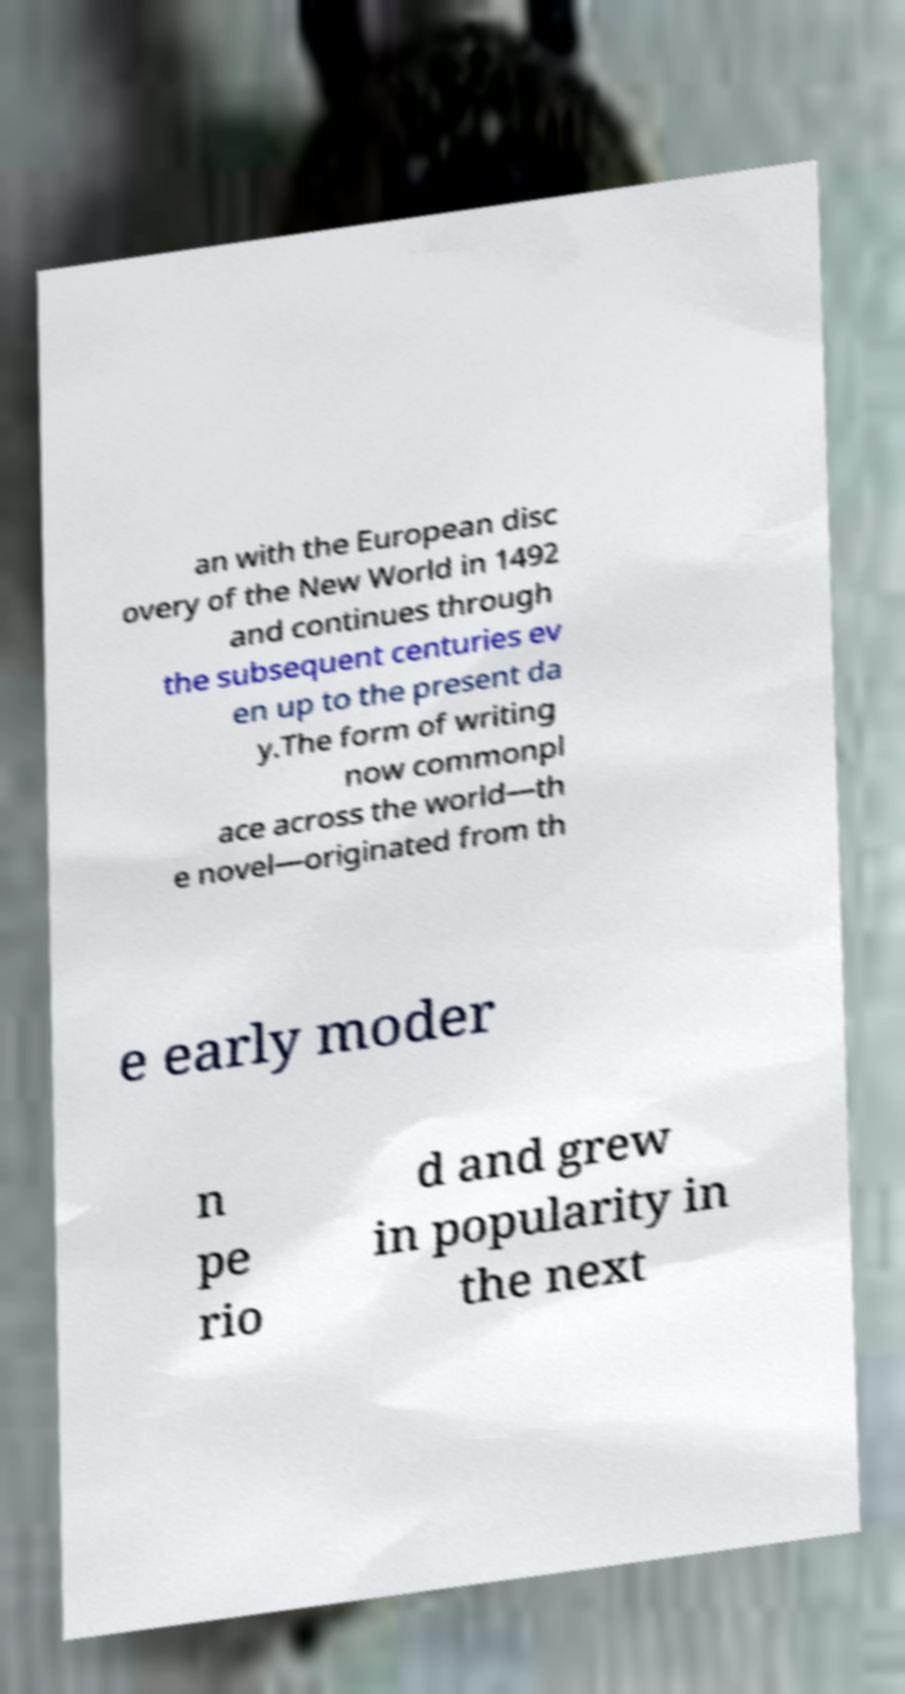Please identify and transcribe the text found in this image. an with the European disc overy of the New World in 1492 and continues through the subsequent centuries ev en up to the present da y.The form of writing now commonpl ace across the world—th e novel—originated from th e early moder n pe rio d and grew in popularity in the next 